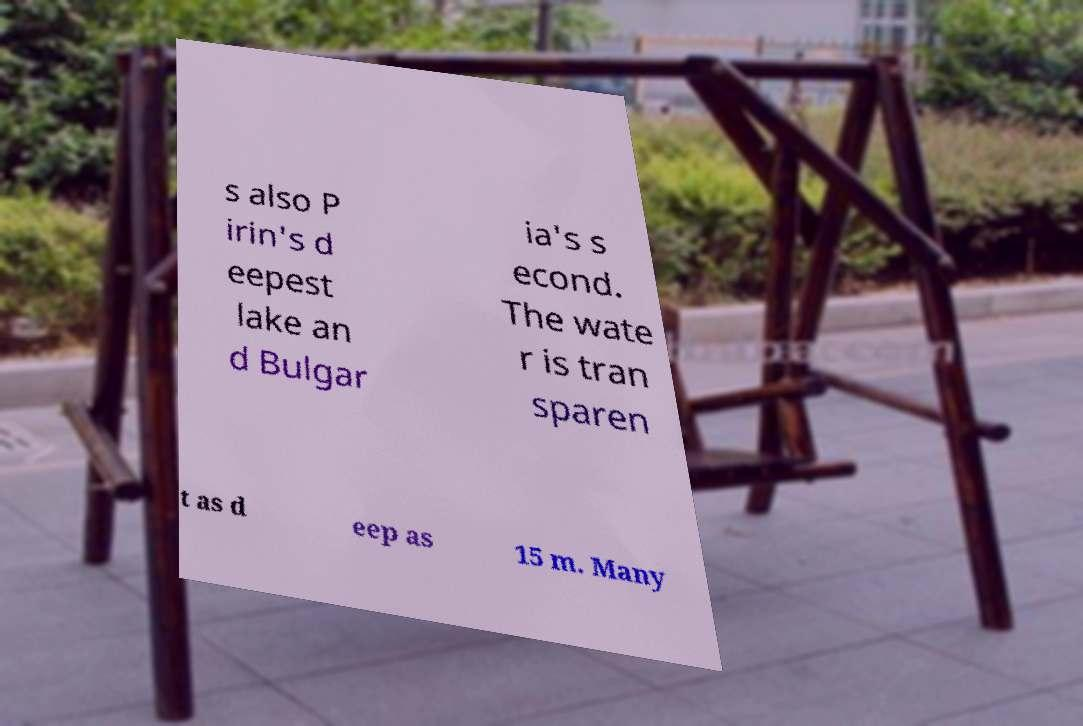Could you extract and type out the text from this image? s also P irin's d eepest lake an d Bulgar ia's s econd. The wate r is tran sparen t as d eep as 15 m. Many 